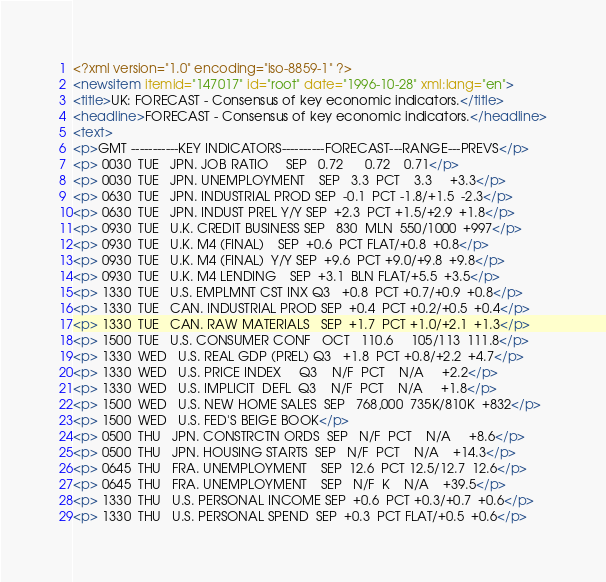<code> <loc_0><loc_0><loc_500><loc_500><_XML_><?xml version="1.0" encoding="iso-8859-1" ?>
<newsitem itemid="147017" id="root" date="1996-10-28" xml:lang="en">
<title>UK: FORECAST - Consensus of key economic indicators.</title>
<headline>FORECAST - Consensus of key economic indicators.</headline>
<text>
<p>GMT -----------KEY INDICATORS----------FORECAST---RANGE---PREVS</p>
<p> 0030  TUE   JPN. JOB RATIO	 SEP   0.72	  0.72    0.71</p>
<p> 0030  TUE   JPN. UNEMPLOYMENT    SEP   3.3  PCT    3.3     +3.3</p>
<p> 0630  TUE   JPN. INDUSTRIAL PROD SEP  -0.1  PCT -1.8/+1.5  -2.3</p>
<p> 0630  TUE   JPN. INDUST PREL Y/Y SEP  +2.3  PCT +1.5/+2.9  +1.8</p>
<p> 0930  TUE   U.K. CREDIT BUSINESS SEP   830  MLN  550/1000  +997</p>
<p> 0930  TUE   U.K. M4 (FINAL)	SEP  +0.6  PCT FLAT/+0.8  +0.8</p>
<p> 0930  TUE   U.K. M4 (FINAL)  Y/Y SEP  +9.6  PCT +9.0/+9.8  +9.8</p>
<p> 0930  TUE   U.K. M4 LENDING	SEP  +3.1  BLN FLAT/+5.5  +3.5</p>
<p> 1330  TUE   U.S. EMPLMNT CST INX Q3   +0.8  PCT +0.7/+0.9  +0.8</p>
<p> 1330  TUE   CAN. INDUSTRIAL PROD SEP  +0.4  PCT +0.2/+0.5  +0.4</p>
<p> 1330  TUE   CAN. RAW MATERIALS   SEP  +1.7  PCT +1.0/+2.1  +1.3</p>
<p> 1500  TUE   U.S. CONSUMER CONF   OCT   110.6     105/113  111.8</p>
<p> 1330  WED   U.S. REAL GDP (PREL) Q3   +1.8  PCT +0.8/+2.2  +4.7</p>
<p> 1330  WED   U.S. PRICE INDEX     Q3    N/F  PCT    N/A     +2.2</p>
<p> 1330  WED   U.S. IMPLICIT  DEFL  Q3    N/F  PCT    N/A     +1.8</p>
<p> 1500  WED   U.S. NEW HOME SALES  SEP   768,000  735K/810K  +832</p>
<p> 1500  WED   U.S. FED'S BEIGE BOOK</p>
<p> 0500  THU   JPN. CONSTRCTN ORDS  SEP   N/F  PCT    N/A     +8.6</p>
<p> 0500  THU   JPN. HOUSING STARTS  SEP   N/F  PCT    N/A    +14.3</p>
<p> 0645  THU   FRA. UNEMPLOYMENT    SEP  12.6  PCT 12.5/12.7  12.6</p>
<p> 0645  THU   FRA. UNEMPLOYMENT    SEP   N/F  K	N/A    +39.5</p>
<p> 1330  THU   U.S. PERSONAL INCOME SEP  +0.6  PCT +0.3/+0.7  +0.6</p>
<p> 1330  THU   U.S. PERSONAL SPEND  SEP  +0.3  PCT FLAT/+0.5  +0.6</p></code> 